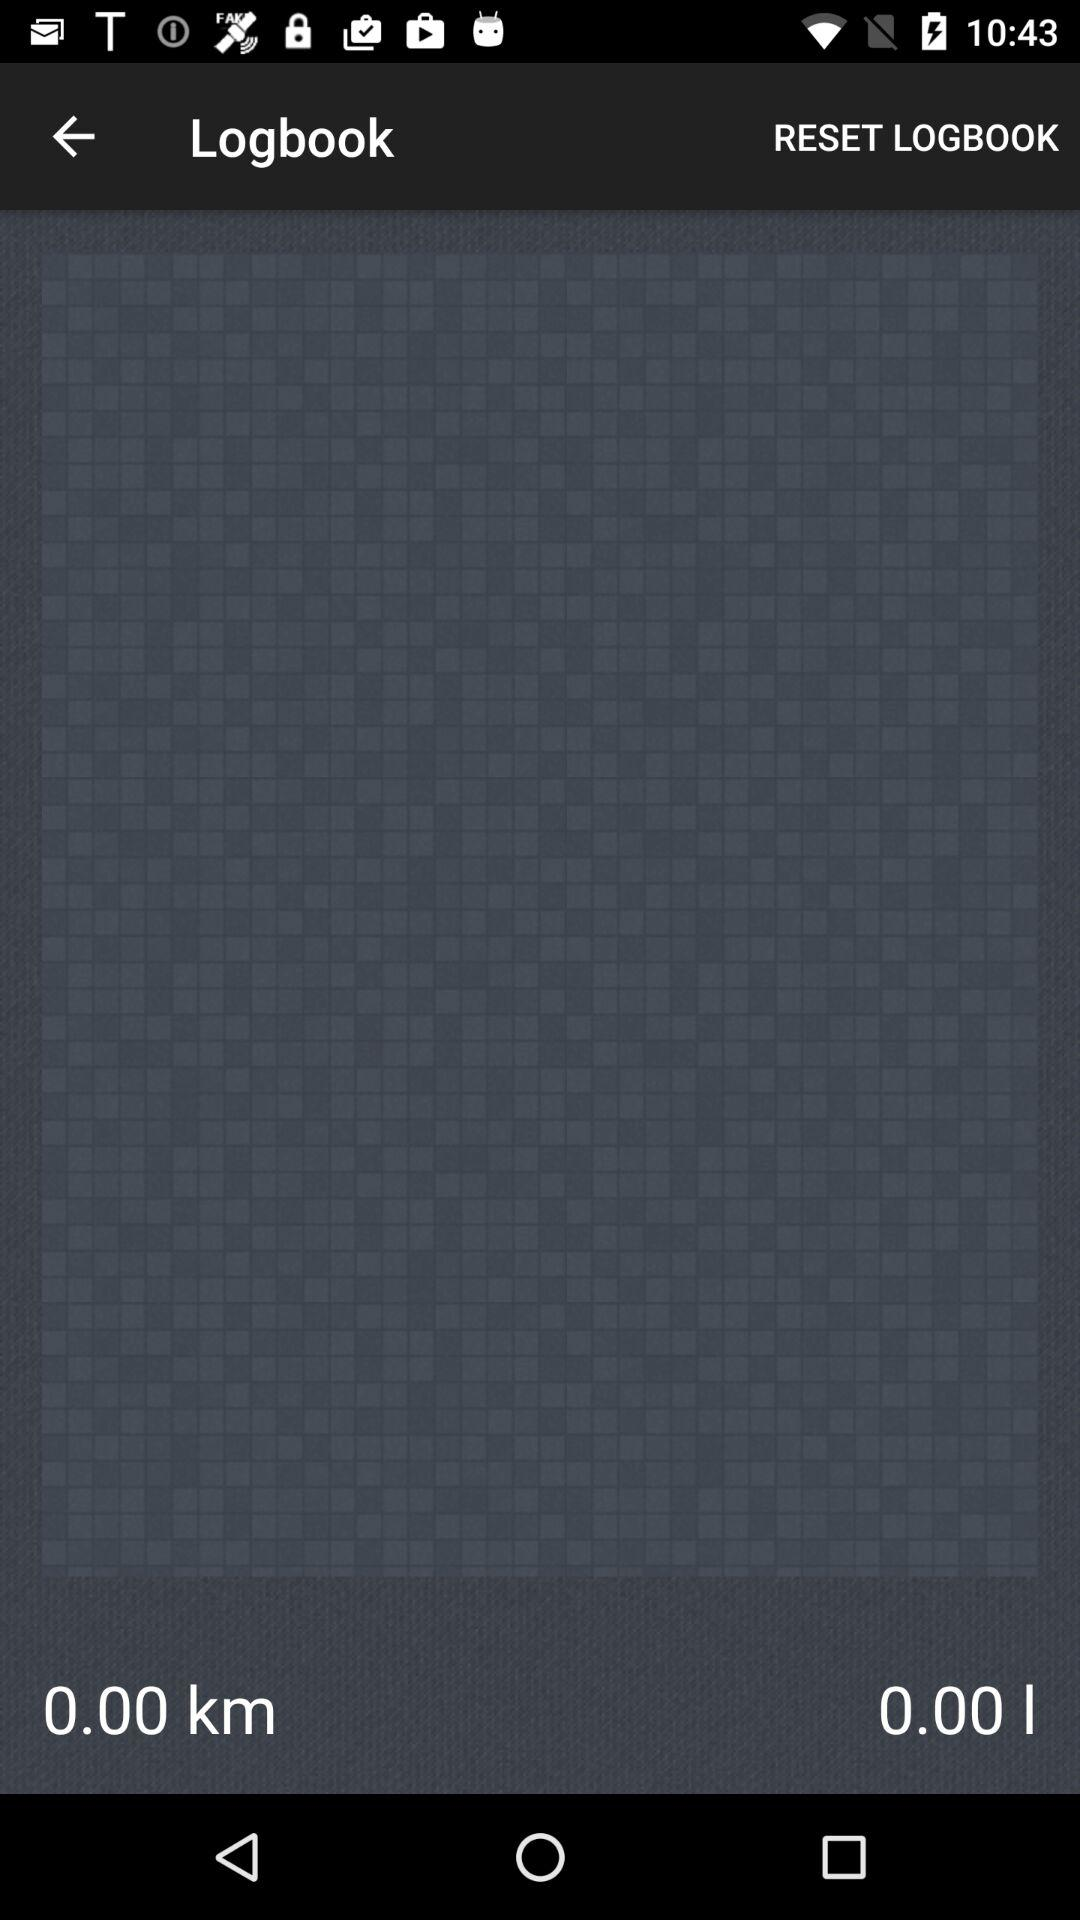What is the distance in km? The distance is 0.00. 